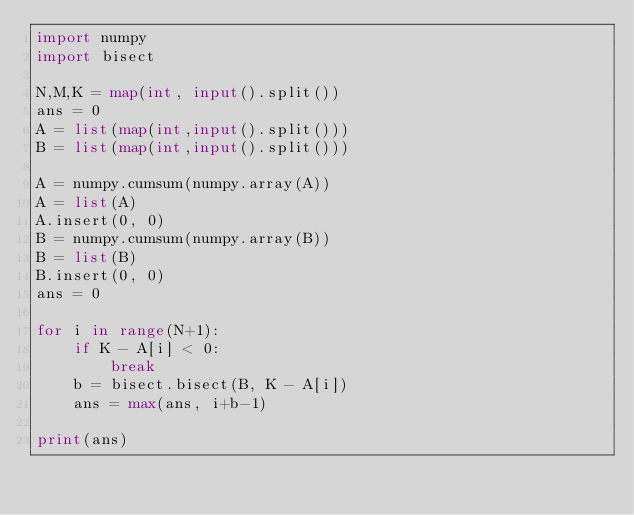Convert code to text. <code><loc_0><loc_0><loc_500><loc_500><_Python_>import numpy
import bisect

N,M,K = map(int, input().split())
ans = 0
A = list(map(int,input().split()))
B = list(map(int,input().split()))

A = numpy.cumsum(numpy.array(A))
A = list(A)
A.insert(0, 0)
B = numpy.cumsum(numpy.array(B))
B = list(B)
B.insert(0, 0)
ans = 0

for i in range(N+1):
    if K - A[i] < 0:
        break
    b = bisect.bisect(B, K - A[i])
    ans = max(ans, i+b-1)

print(ans)</code> 